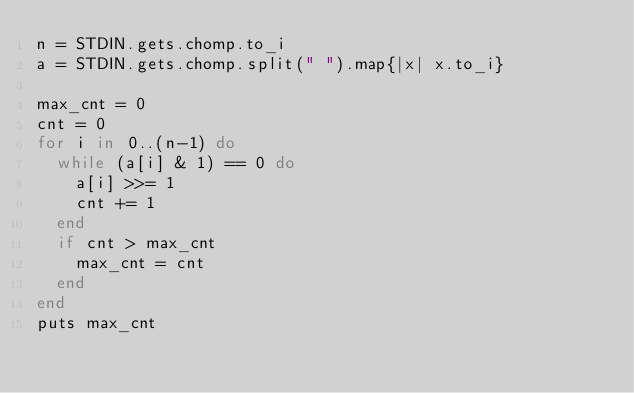Convert code to text. <code><loc_0><loc_0><loc_500><loc_500><_Ruby_>n = STDIN.gets.chomp.to_i
a = STDIN.gets.chomp.split(" ").map{|x| x.to_i}

max_cnt = 0
cnt = 0
for i in 0..(n-1) do
  while (a[i] & 1) == 0 do
    a[i] >>= 1
    cnt += 1
  end
  if cnt > max_cnt
    max_cnt = cnt
  end
end
puts max_cnt</code> 